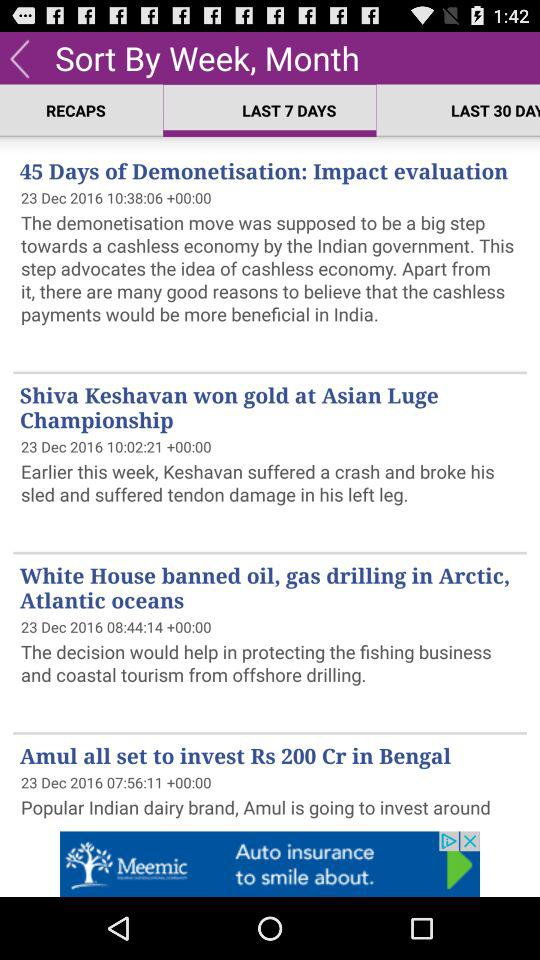For how many days has the impact of demonetisation been evaluated? The impact for 45 days of demonetisation has been evaluated. 